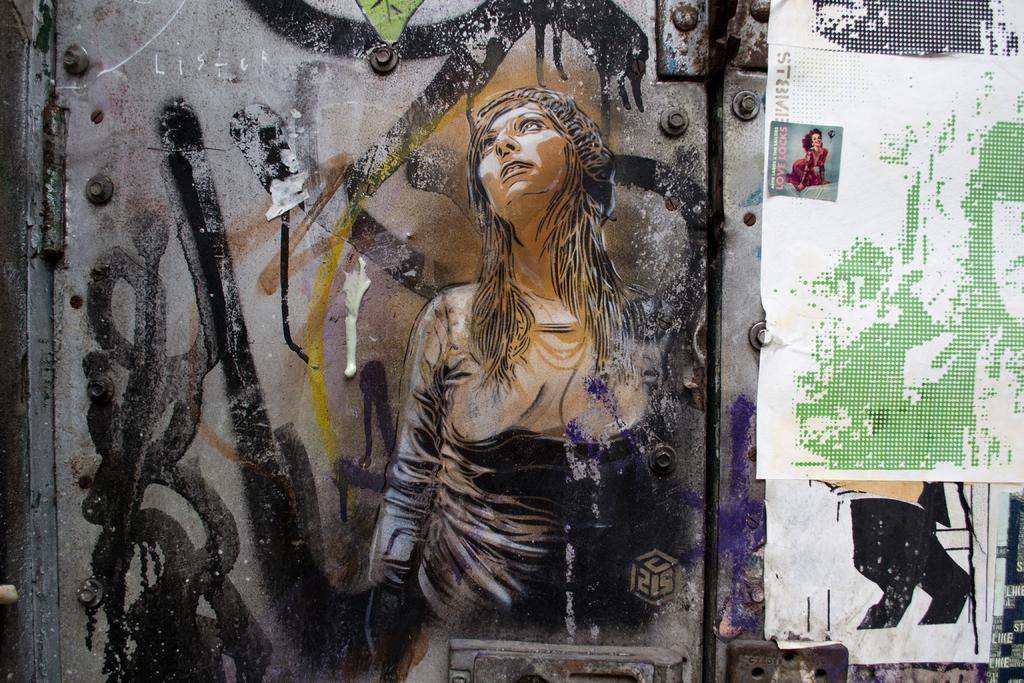Please provide a concise description of this image. As we can see in the image there is a wall. On wall there is a painting of a woman and a poster. 